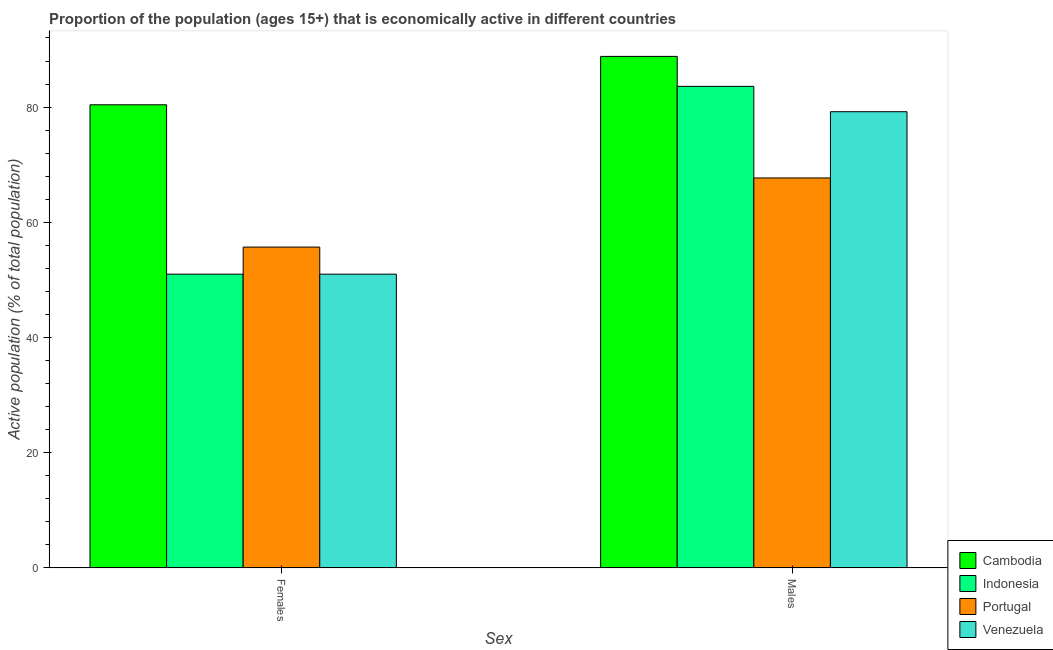How many different coloured bars are there?
Offer a very short reply. 4. Are the number of bars per tick equal to the number of legend labels?
Offer a terse response. Yes. What is the label of the 2nd group of bars from the left?
Your answer should be compact. Males. What is the percentage of economically active male population in Cambodia?
Make the answer very short. 88.8. Across all countries, what is the maximum percentage of economically active female population?
Offer a terse response. 80.4. Across all countries, what is the minimum percentage of economically active male population?
Keep it short and to the point. 67.7. In which country was the percentage of economically active female population maximum?
Your answer should be very brief. Cambodia. What is the total percentage of economically active female population in the graph?
Your answer should be compact. 238.1. What is the difference between the percentage of economically active male population in Venezuela and that in Portugal?
Make the answer very short. 11.5. What is the difference between the percentage of economically active female population in Indonesia and the percentage of economically active male population in Venezuela?
Provide a short and direct response. -28.2. What is the average percentage of economically active male population per country?
Keep it short and to the point. 79.82. What is the difference between the percentage of economically active female population and percentage of economically active male population in Venezuela?
Provide a succinct answer. -28.2. In how many countries, is the percentage of economically active female population greater than 72 %?
Your answer should be compact. 1. What is the ratio of the percentage of economically active female population in Cambodia to that in Indonesia?
Offer a very short reply. 1.58. What does the 4th bar from the left in Females represents?
Offer a terse response. Venezuela. What does the 4th bar from the right in Males represents?
Make the answer very short. Cambodia. Are all the bars in the graph horizontal?
Keep it short and to the point. No. How many countries are there in the graph?
Make the answer very short. 4. Are the values on the major ticks of Y-axis written in scientific E-notation?
Your answer should be compact. No. Does the graph contain any zero values?
Make the answer very short. No. Where does the legend appear in the graph?
Provide a succinct answer. Bottom right. How many legend labels are there?
Give a very brief answer. 4. What is the title of the graph?
Offer a very short reply. Proportion of the population (ages 15+) that is economically active in different countries. What is the label or title of the X-axis?
Your answer should be very brief. Sex. What is the label or title of the Y-axis?
Provide a succinct answer. Active population (% of total population). What is the Active population (% of total population) of Cambodia in Females?
Make the answer very short. 80.4. What is the Active population (% of total population) in Portugal in Females?
Your response must be concise. 55.7. What is the Active population (% of total population) in Cambodia in Males?
Provide a short and direct response. 88.8. What is the Active population (% of total population) in Indonesia in Males?
Offer a very short reply. 83.6. What is the Active population (% of total population) in Portugal in Males?
Provide a short and direct response. 67.7. What is the Active population (% of total population) in Venezuela in Males?
Provide a short and direct response. 79.2. Across all Sex, what is the maximum Active population (% of total population) of Cambodia?
Your response must be concise. 88.8. Across all Sex, what is the maximum Active population (% of total population) in Indonesia?
Make the answer very short. 83.6. Across all Sex, what is the maximum Active population (% of total population) in Portugal?
Make the answer very short. 67.7. Across all Sex, what is the maximum Active population (% of total population) in Venezuela?
Offer a terse response. 79.2. Across all Sex, what is the minimum Active population (% of total population) of Cambodia?
Give a very brief answer. 80.4. Across all Sex, what is the minimum Active population (% of total population) in Portugal?
Provide a succinct answer. 55.7. What is the total Active population (% of total population) in Cambodia in the graph?
Your answer should be very brief. 169.2. What is the total Active population (% of total population) of Indonesia in the graph?
Your response must be concise. 134.6. What is the total Active population (% of total population) of Portugal in the graph?
Provide a short and direct response. 123.4. What is the total Active population (% of total population) in Venezuela in the graph?
Keep it short and to the point. 130.2. What is the difference between the Active population (% of total population) of Cambodia in Females and that in Males?
Provide a succinct answer. -8.4. What is the difference between the Active population (% of total population) of Indonesia in Females and that in Males?
Make the answer very short. -32.6. What is the difference between the Active population (% of total population) in Venezuela in Females and that in Males?
Give a very brief answer. -28.2. What is the difference between the Active population (% of total population) in Cambodia in Females and the Active population (% of total population) in Indonesia in Males?
Give a very brief answer. -3.2. What is the difference between the Active population (% of total population) in Cambodia in Females and the Active population (% of total population) in Venezuela in Males?
Keep it short and to the point. 1.2. What is the difference between the Active population (% of total population) in Indonesia in Females and the Active population (% of total population) in Portugal in Males?
Offer a terse response. -16.7. What is the difference between the Active population (% of total population) in Indonesia in Females and the Active population (% of total population) in Venezuela in Males?
Provide a short and direct response. -28.2. What is the difference between the Active population (% of total population) in Portugal in Females and the Active population (% of total population) in Venezuela in Males?
Your response must be concise. -23.5. What is the average Active population (% of total population) in Cambodia per Sex?
Your response must be concise. 84.6. What is the average Active population (% of total population) of Indonesia per Sex?
Your answer should be very brief. 67.3. What is the average Active population (% of total population) in Portugal per Sex?
Provide a short and direct response. 61.7. What is the average Active population (% of total population) of Venezuela per Sex?
Give a very brief answer. 65.1. What is the difference between the Active population (% of total population) in Cambodia and Active population (% of total population) in Indonesia in Females?
Your answer should be very brief. 29.4. What is the difference between the Active population (% of total population) of Cambodia and Active population (% of total population) of Portugal in Females?
Ensure brevity in your answer.  24.7. What is the difference between the Active population (% of total population) of Cambodia and Active population (% of total population) of Venezuela in Females?
Your answer should be compact. 29.4. What is the difference between the Active population (% of total population) in Indonesia and Active population (% of total population) in Portugal in Females?
Give a very brief answer. -4.7. What is the difference between the Active population (% of total population) in Indonesia and Active population (% of total population) in Venezuela in Females?
Make the answer very short. 0. What is the difference between the Active population (% of total population) in Cambodia and Active population (% of total population) in Portugal in Males?
Your answer should be very brief. 21.1. What is the difference between the Active population (% of total population) in Cambodia and Active population (% of total population) in Venezuela in Males?
Make the answer very short. 9.6. What is the ratio of the Active population (% of total population) of Cambodia in Females to that in Males?
Offer a terse response. 0.91. What is the ratio of the Active population (% of total population) in Indonesia in Females to that in Males?
Your answer should be compact. 0.61. What is the ratio of the Active population (% of total population) of Portugal in Females to that in Males?
Your answer should be compact. 0.82. What is the ratio of the Active population (% of total population) of Venezuela in Females to that in Males?
Make the answer very short. 0.64. What is the difference between the highest and the second highest Active population (% of total population) in Cambodia?
Keep it short and to the point. 8.4. What is the difference between the highest and the second highest Active population (% of total population) in Indonesia?
Offer a terse response. 32.6. What is the difference between the highest and the second highest Active population (% of total population) in Portugal?
Your answer should be very brief. 12. What is the difference between the highest and the second highest Active population (% of total population) of Venezuela?
Provide a short and direct response. 28.2. What is the difference between the highest and the lowest Active population (% of total population) of Indonesia?
Give a very brief answer. 32.6. What is the difference between the highest and the lowest Active population (% of total population) of Venezuela?
Provide a short and direct response. 28.2. 